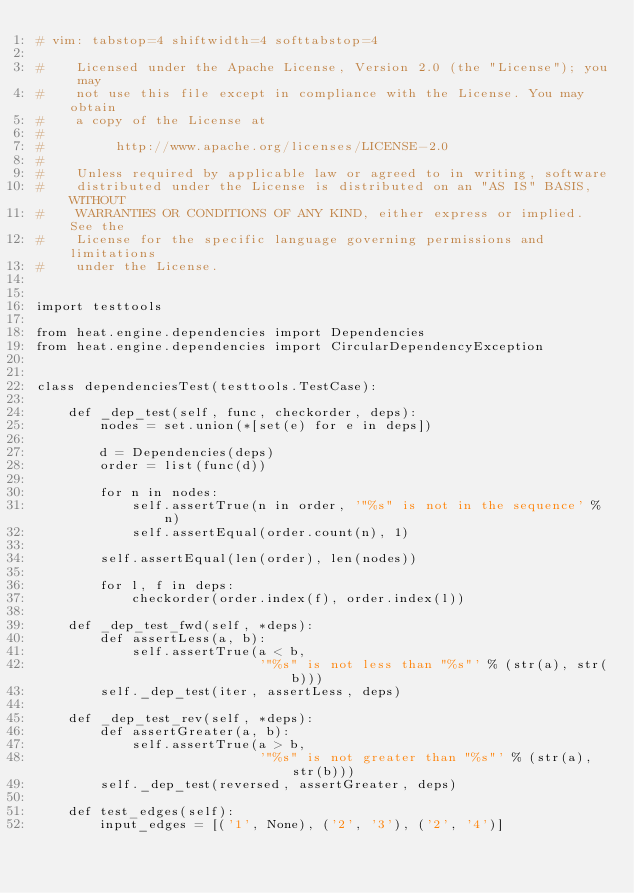<code> <loc_0><loc_0><loc_500><loc_500><_Python_># vim: tabstop=4 shiftwidth=4 softtabstop=4

#    Licensed under the Apache License, Version 2.0 (the "License"); you may
#    not use this file except in compliance with the License. You may obtain
#    a copy of the License at
#
#         http://www.apache.org/licenses/LICENSE-2.0
#
#    Unless required by applicable law or agreed to in writing, software
#    distributed under the License is distributed on an "AS IS" BASIS, WITHOUT
#    WARRANTIES OR CONDITIONS OF ANY KIND, either express or implied. See the
#    License for the specific language governing permissions and limitations
#    under the License.


import testtools

from heat.engine.dependencies import Dependencies
from heat.engine.dependencies import CircularDependencyException


class dependenciesTest(testtools.TestCase):

    def _dep_test(self, func, checkorder, deps):
        nodes = set.union(*[set(e) for e in deps])

        d = Dependencies(deps)
        order = list(func(d))

        for n in nodes:
            self.assertTrue(n in order, '"%s" is not in the sequence' % n)
            self.assertEqual(order.count(n), 1)

        self.assertEqual(len(order), len(nodes))

        for l, f in deps:
            checkorder(order.index(f), order.index(l))

    def _dep_test_fwd(self, *deps):
        def assertLess(a, b):
            self.assertTrue(a < b,
                            '"%s" is not less than "%s"' % (str(a), str(b)))
        self._dep_test(iter, assertLess, deps)

    def _dep_test_rev(self, *deps):
        def assertGreater(a, b):
            self.assertTrue(a > b,
                            '"%s" is not greater than "%s"' % (str(a), str(b)))
        self._dep_test(reversed, assertGreater, deps)

    def test_edges(self):
        input_edges = [('1', None), ('2', '3'), ('2', '4')]</code> 